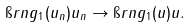<formula> <loc_0><loc_0><loc_500><loc_500>\i r n g _ { 1 } ( u _ { n } ) u _ { n } \to \i r n g _ { 1 } ( u ) u .</formula> 